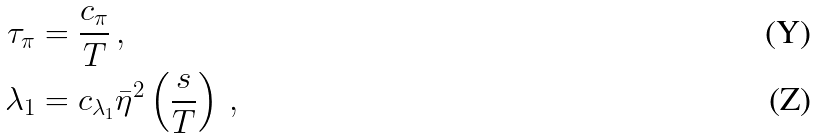Convert formula to latex. <formula><loc_0><loc_0><loc_500><loc_500>\tau _ { \pi } & = \frac { c _ { \pi } } { T } \, , \\ \lambda _ { 1 } & = c _ { \lambda _ { 1 } } \bar { \eta } ^ { 2 } \left ( \frac { s } { T } \right ) \, ,</formula> 